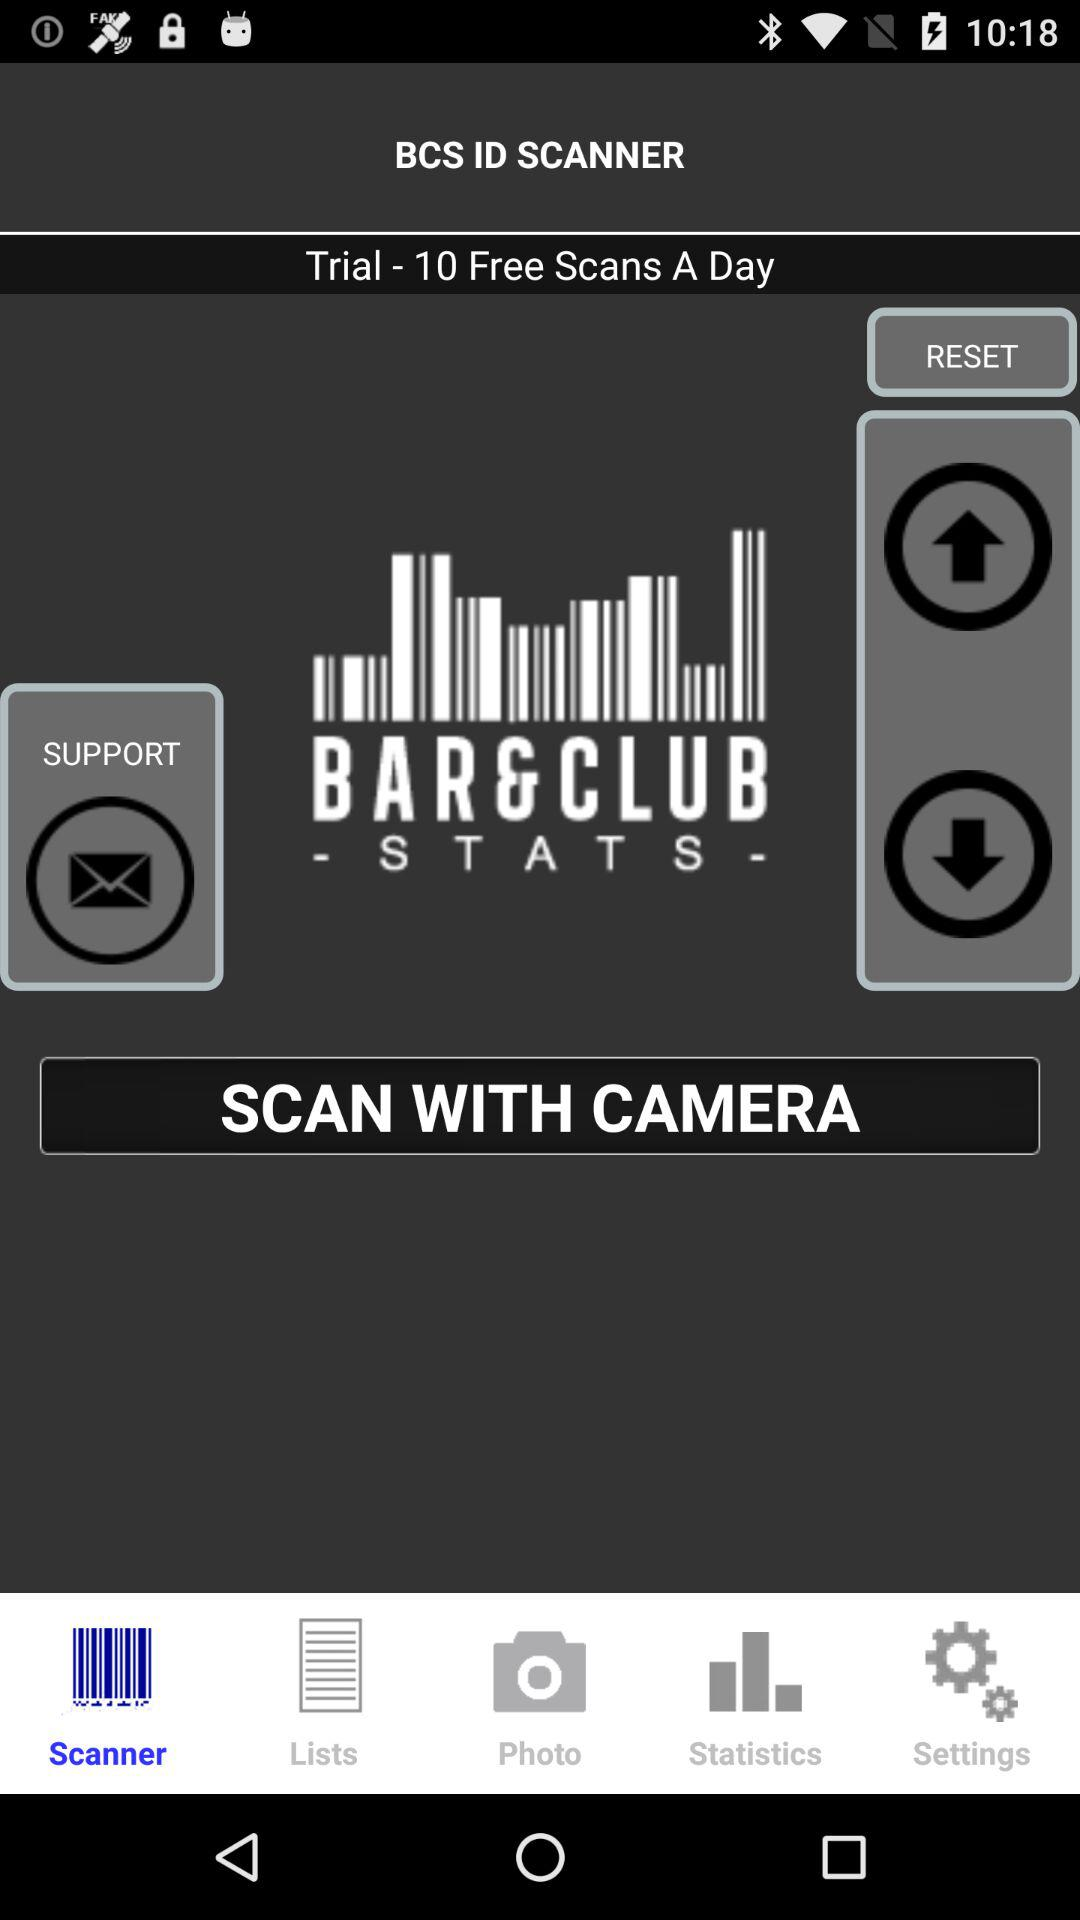How many trials in a day? There are 10 trials in a day. 